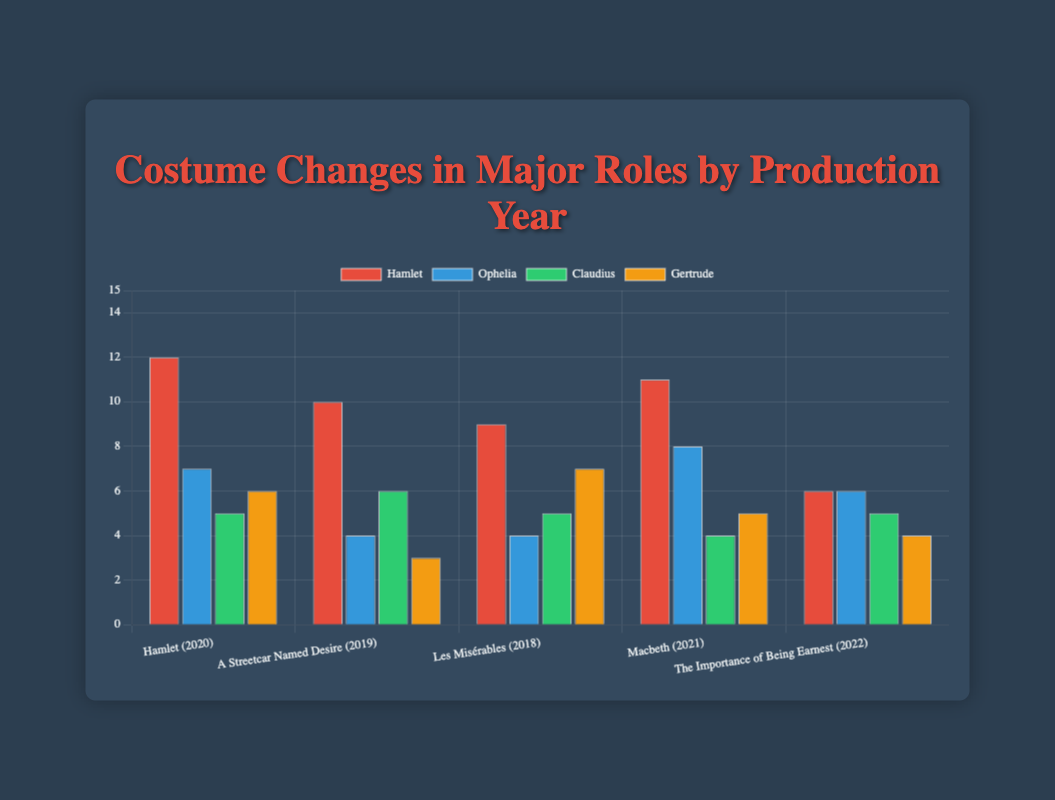How many total costume changes were there in 2020? Sum the costume changes for all roles in the 2020 production "Hamlet": 12 (Hamlet) + 7 (Ophelia) + 5 (Claudius) + 6 (Gertrude). The total is 12 + 7 + 5 + 6 = 30.
Answer: 30 Which role has the highest number of costume changes in "Les Misérables"? Look at the data for "Les Misérables" (2018). Compare the costume changes: Jean Valjean (9), Fantine (4), Cosette (5), Javert (7). The highest is Jean Valjean with 9 changes.
Answer: Jean Valjean In which year did the role "Hamlet" have the highest number of costume changes? Review the role "Hamlet" across the given years. Note that "Hamlet" appeared in 2020 with 12 costume changes. There are no other instances of "Hamlet" in the dataset.
Answer: 2020 Compare the costume changes of "Macbeth" and "Lady Macbeth" in 2021. Which one had more changes, and by how many? Look at the 2021 production of "Macbeth". "Macbeth" had 11 changes, "Lady Macbeth" had 8. The difference is 11 - 8 = 3. "Macbeth" had more changes by 3.
Answer: Macbeth, by 3 Which role had the fewest costume changes in the 2019 production of "A Streetcar Named Desire"? Check the 2019 production details. Compare the changes: Blanche DuBois (10), Stanley Kowalski (4), Stella Kowalski (6), Harold Mitchell (3). The fewest changes were by Harold Mitchell.
Answer: Harold Mitchell What is the average number of costume changes for roles in the 2022 production "The Importance of Being Earnest"? Calculate the sum of costume changes for the four roles: John Worthing (6), Algernon Moncrieff (6), Gwendolen Fairfax (5), Cecily Cardew (4). Sum is 6 + 6 + 5 + 4 = 21. Average = 21 / 4 = 5.25.
Answer: 5.25 How does the number of costume changes for Jean Valjean in "Les Misérables" compare to Hamlet in "Hamlet"? Jean Valjean had 9 changes in 2018, and Hamlet had 12 in 2020. Compare the two: 12 > 9, so Hamlet had more changes than Jean Valjean.
Answer: Hamlet had more Which role in this dataset had the most costume changes overall? Sum up costume changes across all years for each role and compare. The calculations show Hamlet in "Hamlet" (12) as the highest single value. No other roles exceed this number.
Answer: Hamlet 